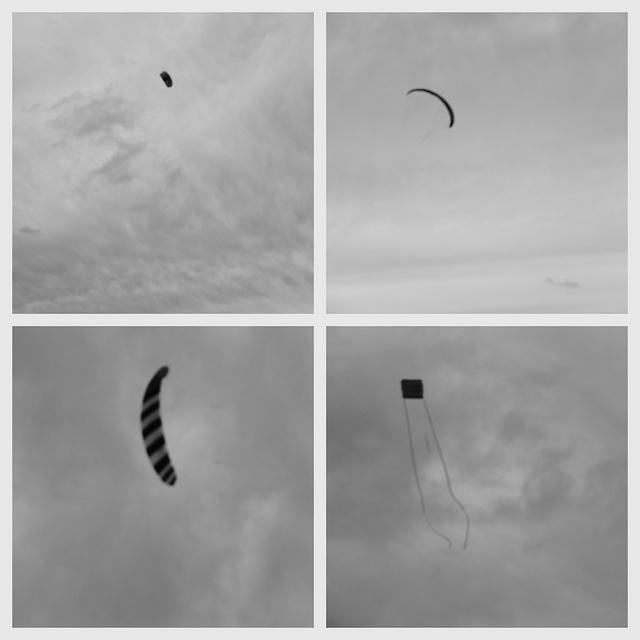What objects do the four frames show?
Short answer required. Kites. Is this picture in color?
Keep it brief. No. Is this 4 different pictures?
Give a very brief answer. Yes. 